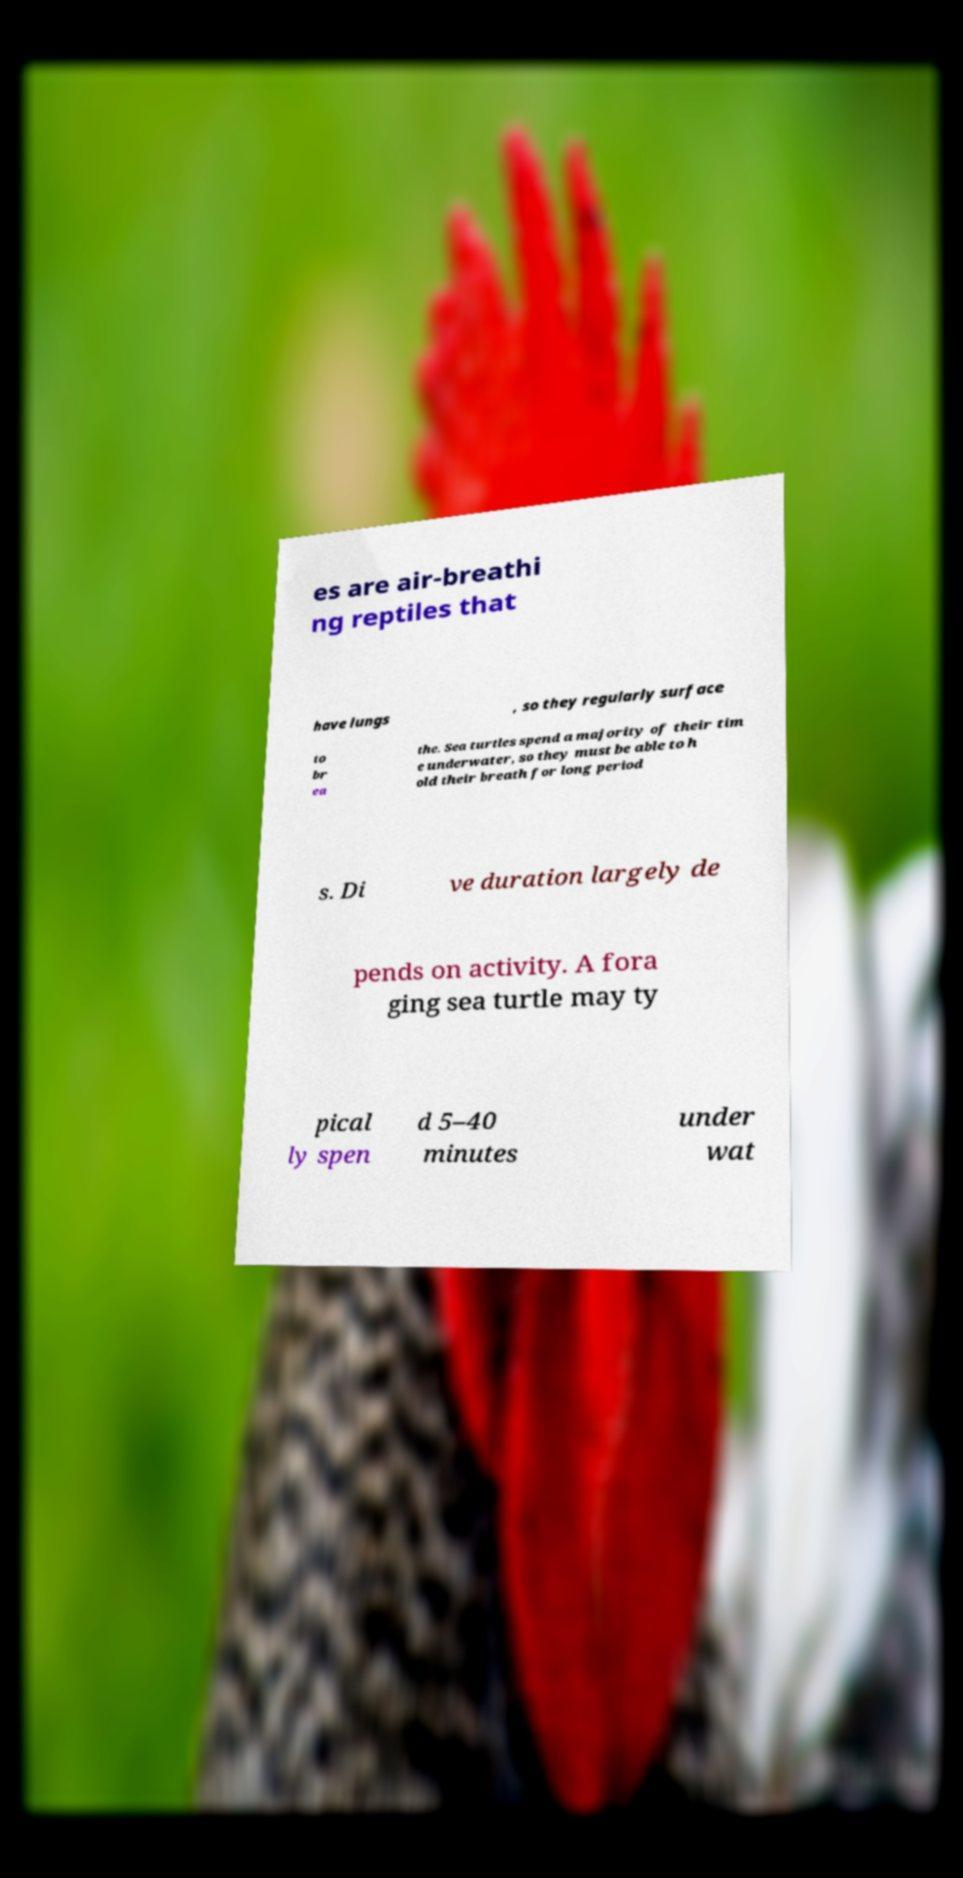I need the written content from this picture converted into text. Can you do that? es are air-breathi ng reptiles that have lungs , so they regularly surface to br ea the. Sea turtles spend a majority of their tim e underwater, so they must be able to h old their breath for long period s. Di ve duration largely de pends on activity. A fora ging sea turtle may ty pical ly spen d 5–40 minutes under wat 